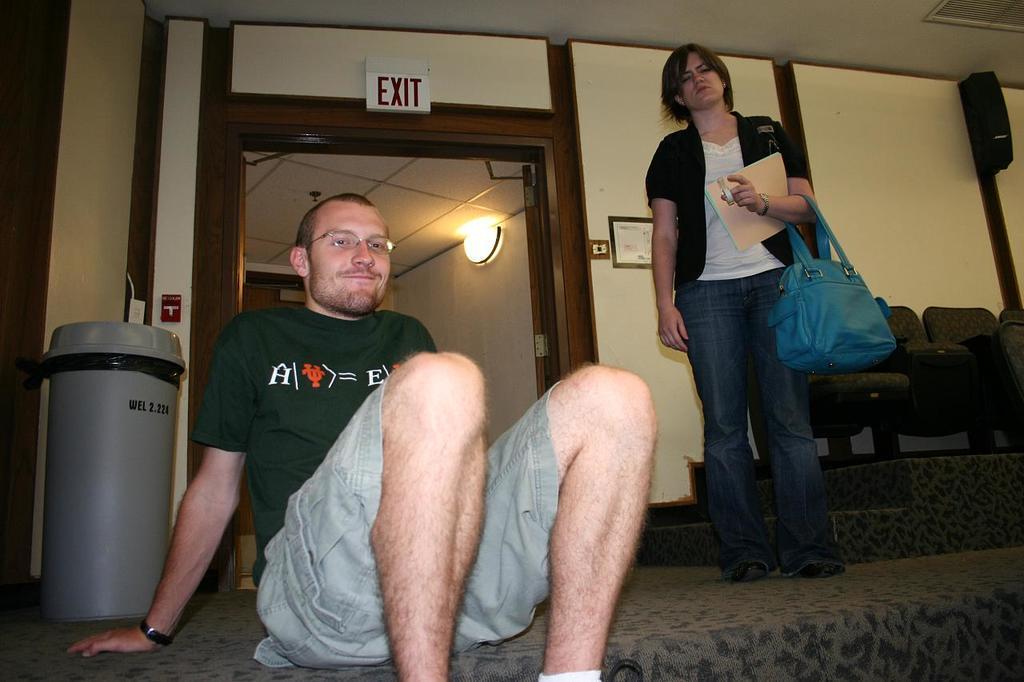Could you give a brief overview of what you see in this image? This is the picture of a room. In this image there is a man sitting and there is a woman standing. At the back there are chairs and there is a dustbin and there is a door and there is a board and there is a poster on the wall. At the top there is a light. At the bottom there is a mat. In the top right there is a speaker. 